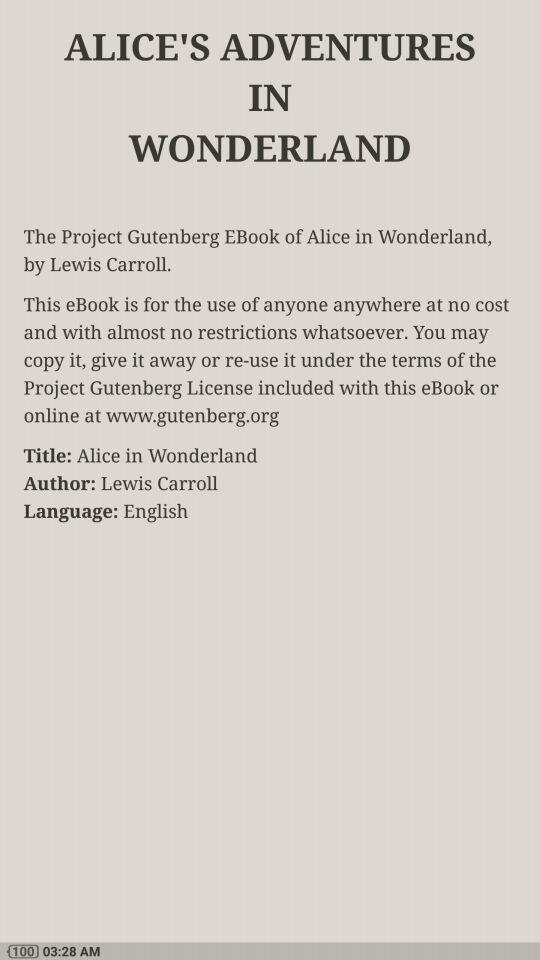What is the language? The language is English. 